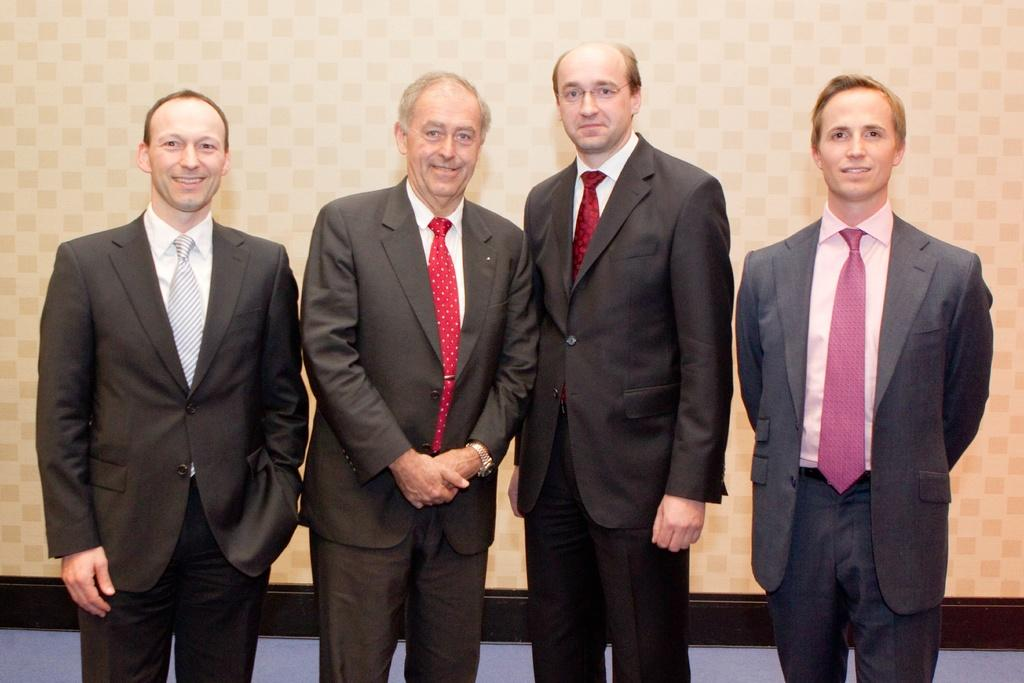What is the main subject of the image? The main subject of the image is men standing in the center. Where are the men standing? The men are standing on the floor. What can be seen in the background of the image? There is a wall in the background of the image. What type of lock can be seen on the wall in the image? There is no lock present on the wall in the image. Can you describe the behavior of the toad in the image? There is no toad present in the image. 